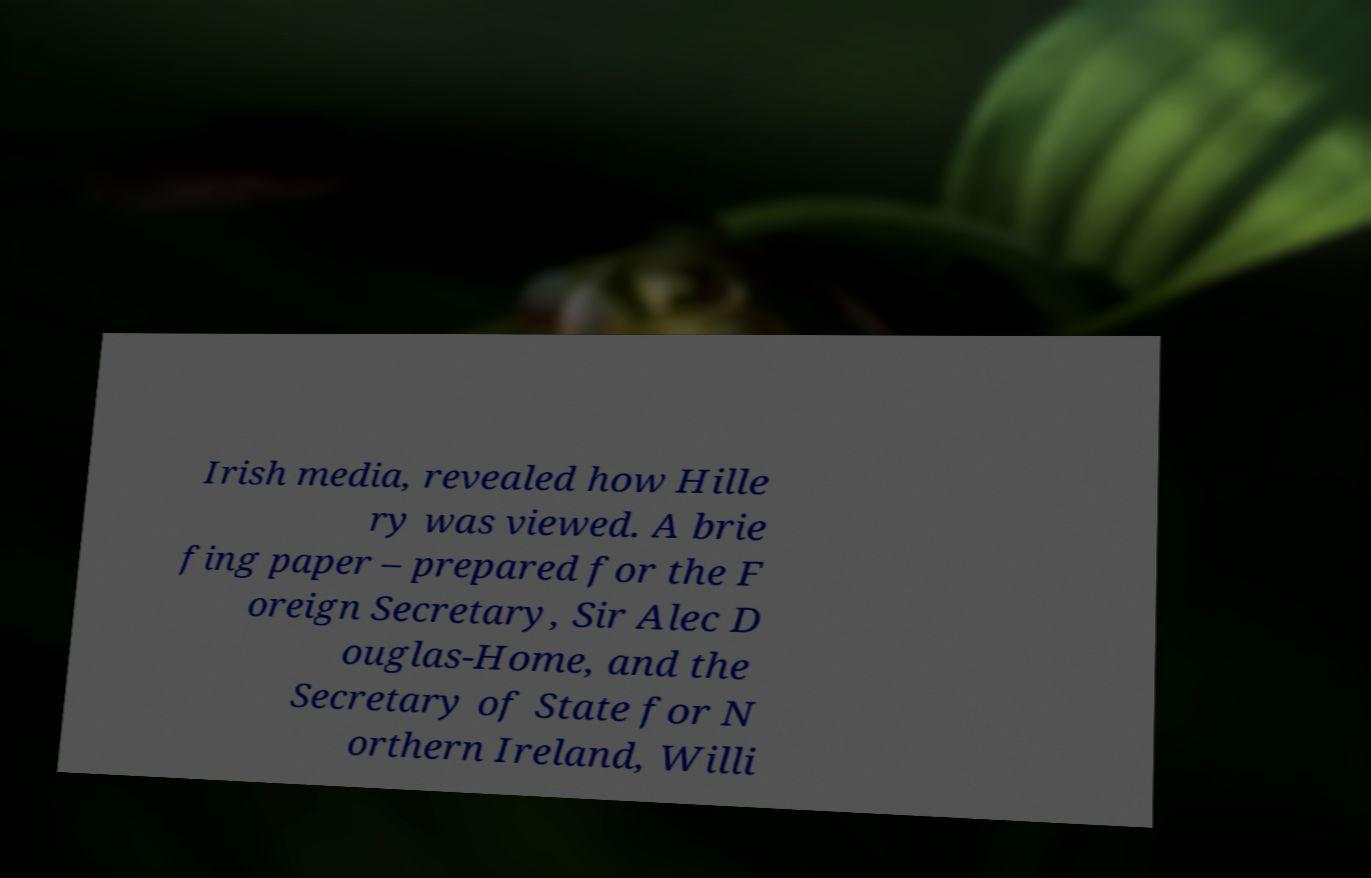What messages or text are displayed in this image? I need them in a readable, typed format. Irish media, revealed how Hille ry was viewed. A brie fing paper – prepared for the F oreign Secretary, Sir Alec D ouglas-Home, and the Secretary of State for N orthern Ireland, Willi 